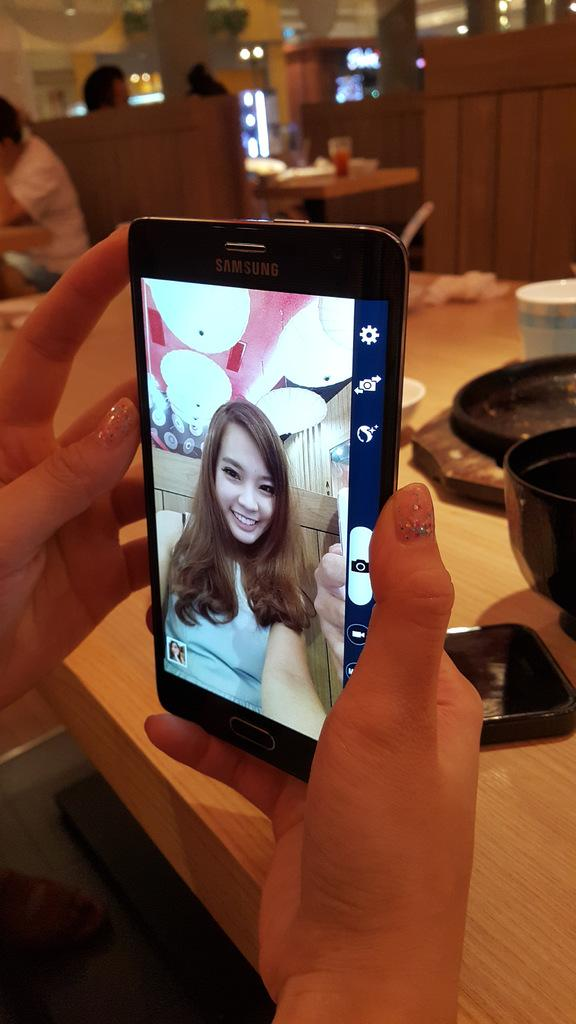What is the person in the image holding? The person in the image is holding a mobile. How many people are sitting in the image? There are three persons sitting in the image. What can be found on the tables in the image? There are objects on the tables in the image. What can be seen in the background of the image? There are lights visible in the background of the image. What type of lip can be seen on the person holding the mobile in the image? There is no lip visible on the person holding the mobile in the image. Is there a rake being used by any of the persons sitting in the image? There is no rake present in the image. 